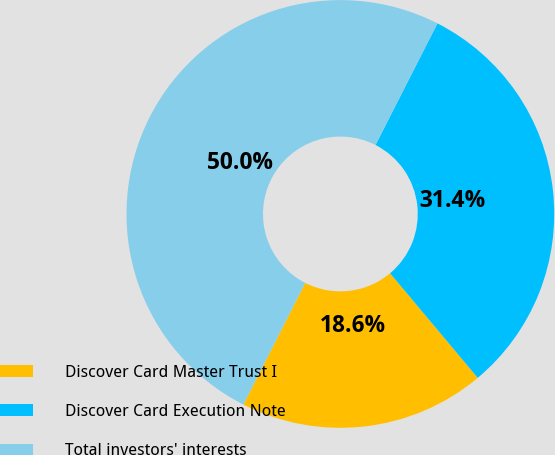Convert chart to OTSL. <chart><loc_0><loc_0><loc_500><loc_500><pie_chart><fcel>Discover Card Master Trust I<fcel>Discover Card Execution Note<fcel>Total investors' interests<nl><fcel>18.6%<fcel>31.4%<fcel>50.0%<nl></chart> 